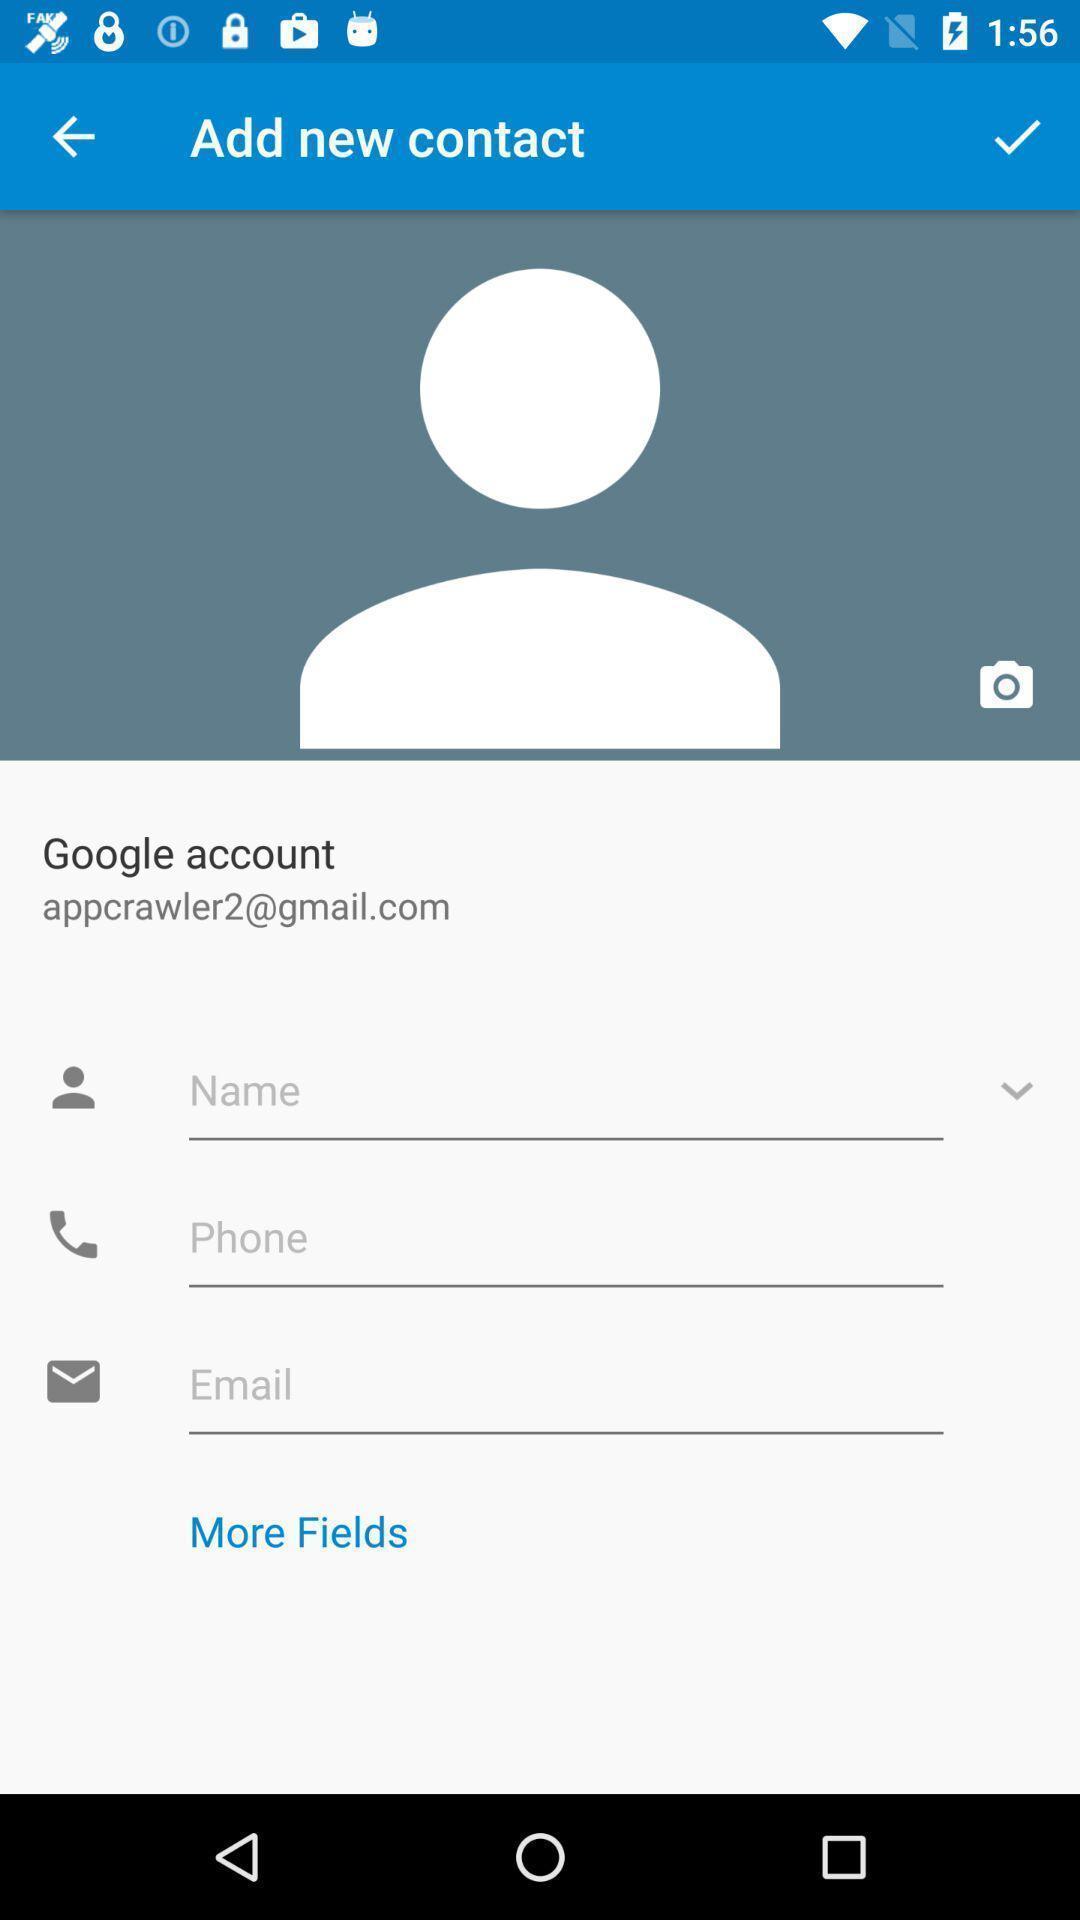Describe the content in this image. Screen shows add contact details. 